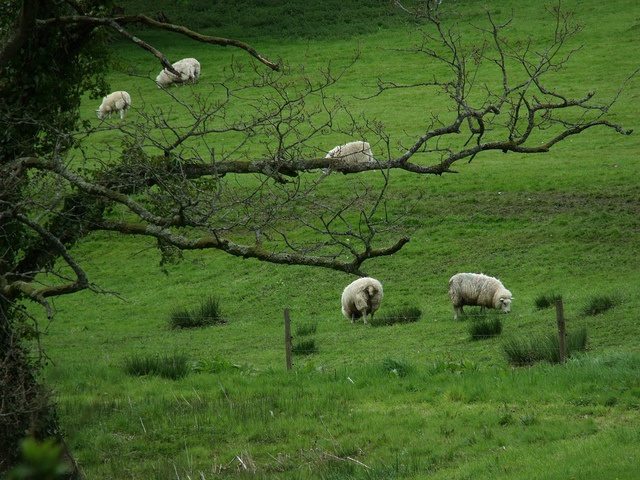Describe the objects in this image and their specific colors. I can see sheep in black, darkgray, gray, and darkgreen tones, sheep in black, gray, darkgreen, and darkgray tones, sheep in black, darkgray, and gray tones, sheep in black, darkgray, gray, and darkgreen tones, and sheep in black, darkgray, gray, and beige tones in this image. 